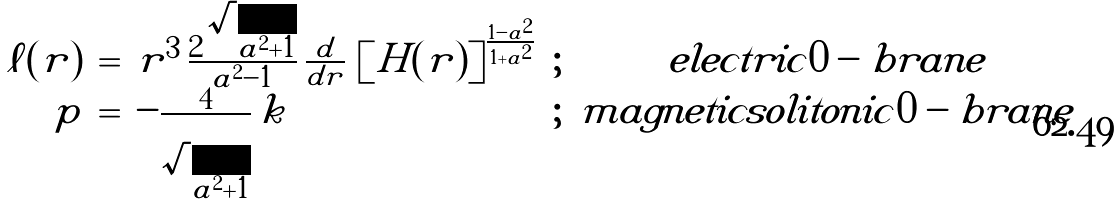<formula> <loc_0><loc_0><loc_500><loc_500>\begin{array} { r c l c c } { \ell ( r ) } & { = } & { { r ^ { 3 } \, \frac { 2 \, \sqrt { a ^ { 2 } + 1 } } { a ^ { 2 } - 1 } \, \frac { d } { d r } \, \left [ H ( r ) \right ] ^ { \frac { 1 - a ^ { 2 } } { 1 + a ^ { 2 } } } } } & { ; } & { e l e c t r i c 0 - b r a n e } \\ { p } & { = } & { { - \frac { 4 } { \sqrt { a ^ { 2 } + 1 } } \, k } } & { ; } & { m a g n e t i c s o l i t o n i c 0 - b r a n e } \end{array}</formula> 